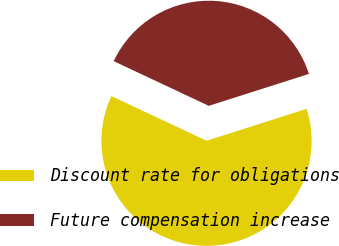Convert chart to OTSL. <chart><loc_0><loc_0><loc_500><loc_500><pie_chart><fcel>Discount rate for obligations<fcel>Future compensation increase<nl><fcel>61.9%<fcel>38.1%<nl></chart> 